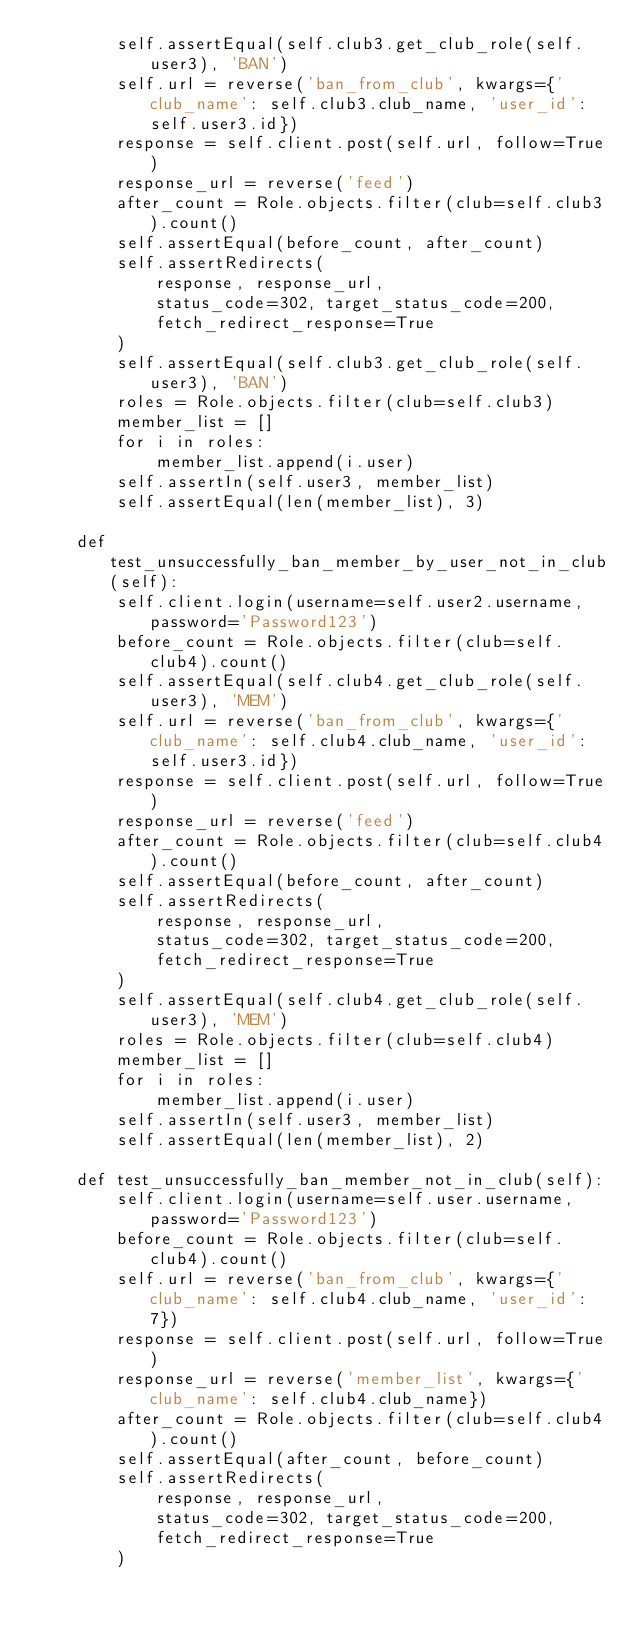Convert code to text. <code><loc_0><loc_0><loc_500><loc_500><_Python_>        self.assertEqual(self.club3.get_club_role(self.user3), 'BAN')
        self.url = reverse('ban_from_club', kwargs={'club_name': self.club3.club_name, 'user_id': self.user3.id})
        response = self.client.post(self.url, follow=True)
        response_url = reverse('feed')
        after_count = Role.objects.filter(club=self.club3).count()
        self.assertEqual(before_count, after_count)
        self.assertRedirects(
            response, response_url,
            status_code=302, target_status_code=200,
            fetch_redirect_response=True
        )
        self.assertEqual(self.club3.get_club_role(self.user3), 'BAN')
        roles = Role.objects.filter(club=self.club3)
        member_list = []
        for i in roles:
            member_list.append(i.user)
        self.assertIn(self.user3, member_list)
        self.assertEqual(len(member_list), 3)

    def test_unsuccessfully_ban_member_by_user_not_in_club(self):
        self.client.login(username=self.user2.username, password='Password123')
        before_count = Role.objects.filter(club=self.club4).count()
        self.assertEqual(self.club4.get_club_role(self.user3), 'MEM')
        self.url = reverse('ban_from_club', kwargs={'club_name': self.club4.club_name, 'user_id': self.user3.id})
        response = self.client.post(self.url, follow=True)
        response_url = reverse('feed')
        after_count = Role.objects.filter(club=self.club4).count()
        self.assertEqual(before_count, after_count)
        self.assertRedirects(
            response, response_url,
            status_code=302, target_status_code=200,
            fetch_redirect_response=True
        )
        self.assertEqual(self.club4.get_club_role(self.user3), 'MEM')
        roles = Role.objects.filter(club=self.club4)
        member_list = []
        for i in roles:
            member_list.append(i.user)
        self.assertIn(self.user3, member_list)
        self.assertEqual(len(member_list), 2)

    def test_unsuccessfully_ban_member_not_in_club(self):
        self.client.login(username=self.user.username, password='Password123')
        before_count = Role.objects.filter(club=self.club4).count()
        self.url = reverse('ban_from_club', kwargs={'club_name': self.club4.club_name, 'user_id': 7})
        response = self.client.post(self.url, follow=True)
        response_url = reverse('member_list', kwargs={'club_name': self.club4.club_name})
        after_count = Role.objects.filter(club=self.club4).count()
        self.assertEqual(after_count, before_count)
        self.assertRedirects(
            response, response_url,
            status_code=302, target_status_code=200,
            fetch_redirect_response=True
        )
</code> 